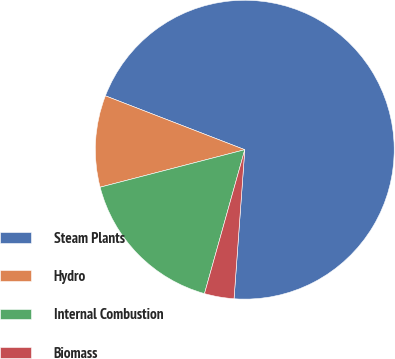Convert chart. <chart><loc_0><loc_0><loc_500><loc_500><pie_chart><fcel>Steam Plants<fcel>Hydro<fcel>Internal Combustion<fcel>Biomass<nl><fcel>70.28%<fcel>9.91%<fcel>16.62%<fcel>3.2%<nl></chart> 